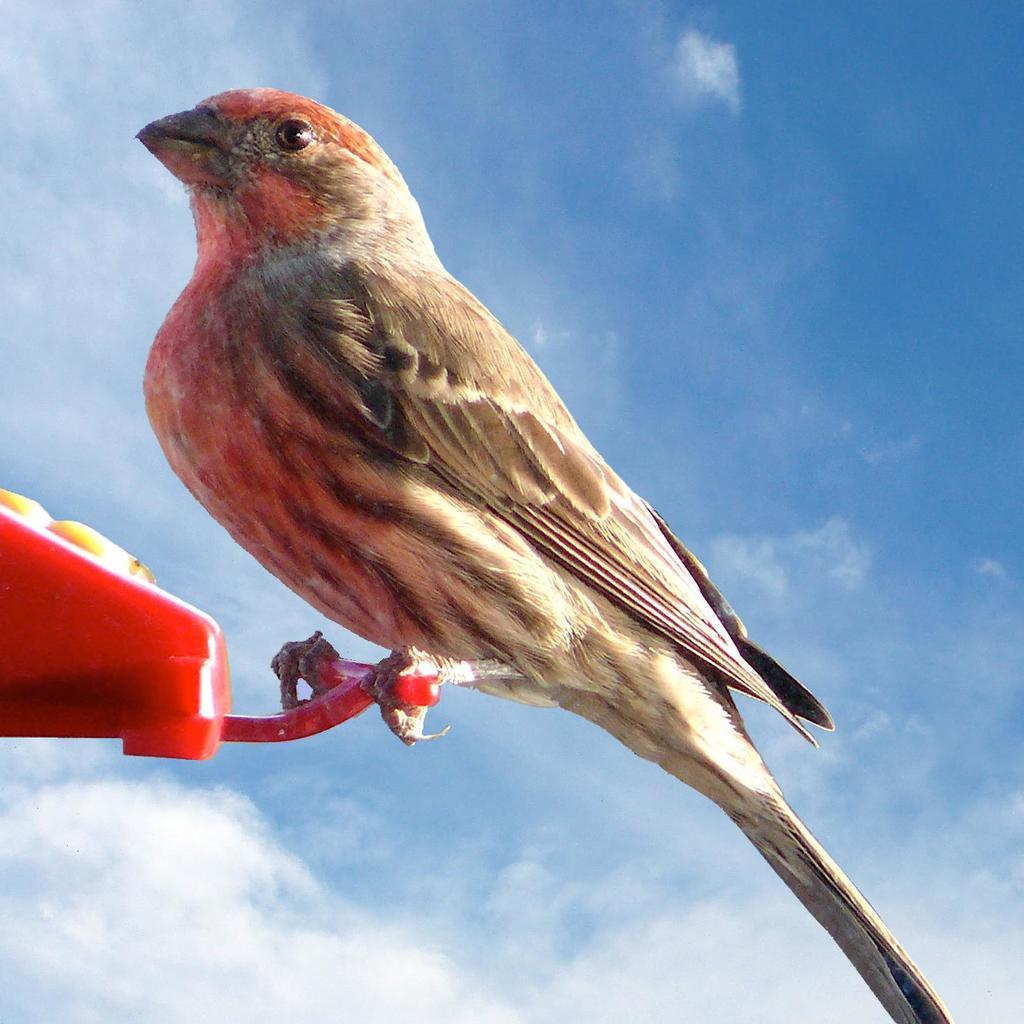What is the main subject of the image? There is an object in the image. What is sitting on the object? A bird is sitting on the object. How would you describe the color of the sky in the image? The sky is blue in the image. Are there any other weather elements visible in the sky? Yes, there are clouds in the sky. What type of cart is being used by the police in the image? There is no cart or police present in the image; it only features an object with a bird sitting on it and a blue sky with clouds. 